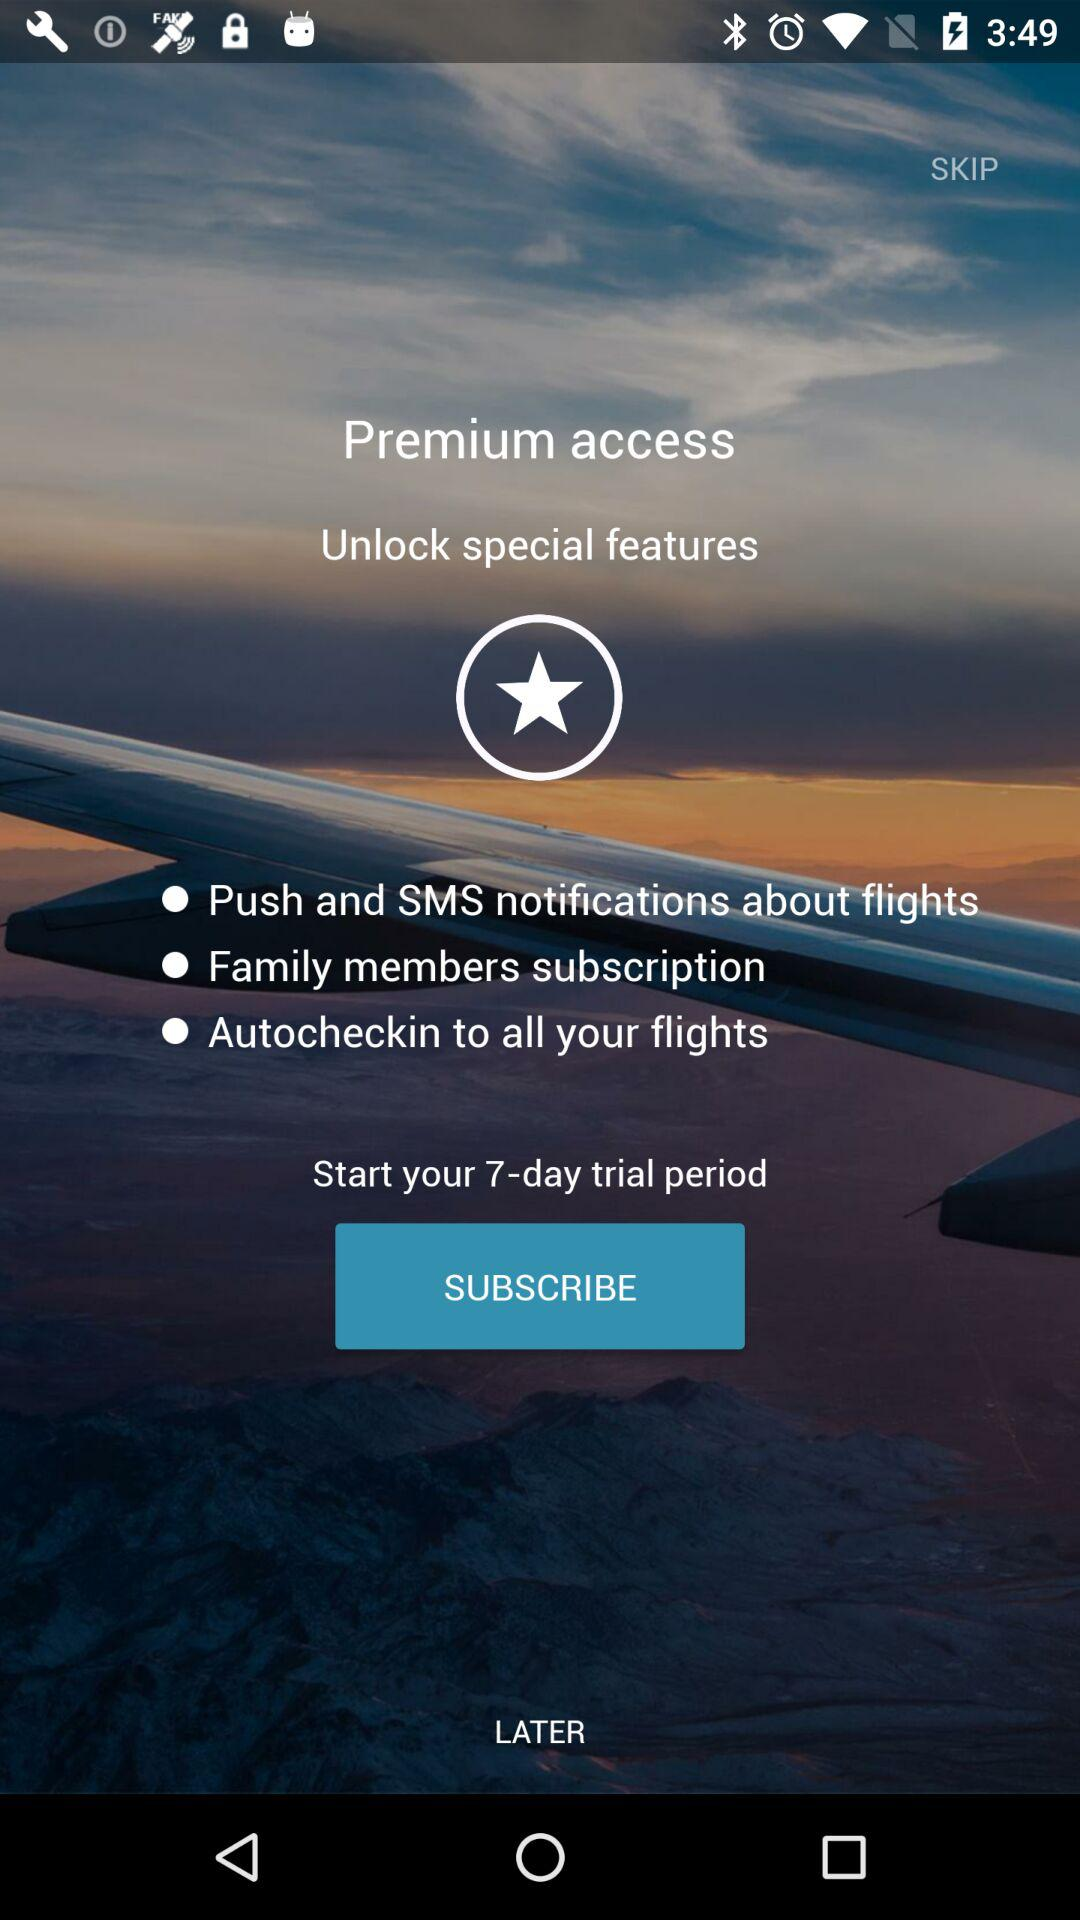How many days are there for the trial period? The number of days is 7. 